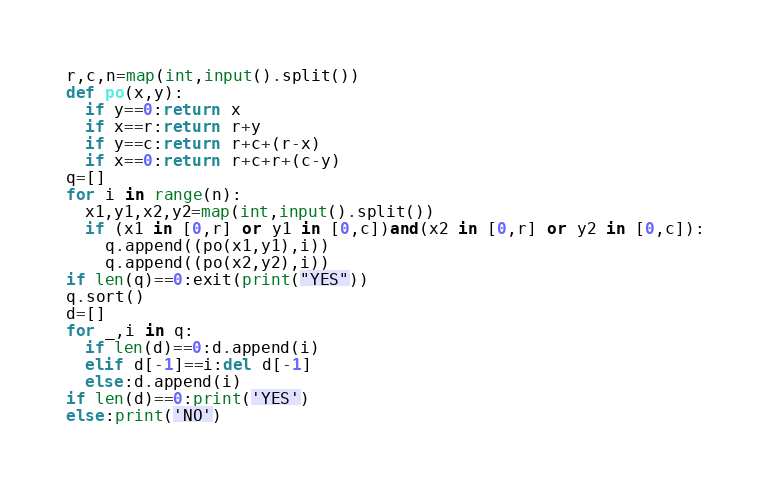<code> <loc_0><loc_0><loc_500><loc_500><_Python_>r,c,n=map(int,input().split())
def po(x,y):
  if y==0:return x
  if x==r:return r+y
  if y==c:return r+c+(r-x)
  if x==0:return r+c+r+(c-y)
q=[]
for i in range(n):
  x1,y1,x2,y2=map(int,input().split())
  if (x1 in [0,r] or y1 in [0,c])and(x2 in [0,r] or y2 in [0,c]):
    q.append((po(x1,y1),i))
    q.append((po(x2,y2),i))
if len(q)==0:exit(print("YES"))
q.sort()
d=[]
for _,i in q:
  if len(d)==0:d.append(i)
  elif d[-1]==i:del d[-1]
  else:d.append(i)
if len(d)==0:print('YES')
else:print('NO')</code> 